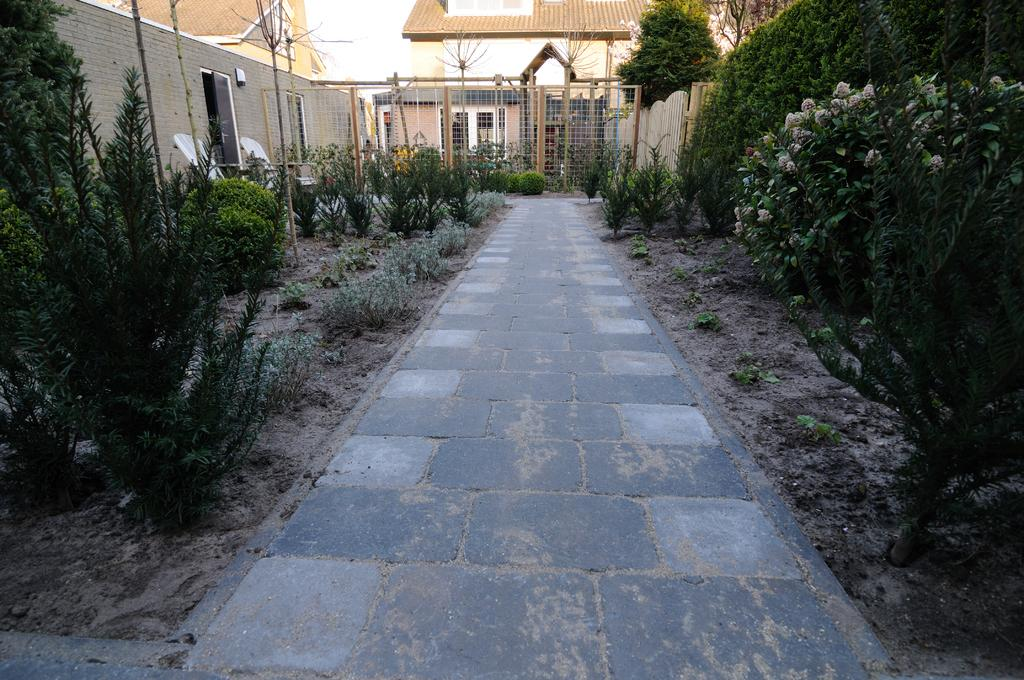What is the main feature in the middle of the image? There is a path in the middle of the image. What can be seen on either side of the path? There are plants and trees on either side of the path. What is visible in the background of the image? There are buildings in the background of the image. What type of boundary can be seen in the image? There is a net boundary visible in the image. What type of coal is being used to fuel the science experiment in the image? There is no coal or science experiment present in the image. What type of plant is growing on the left side of the path in the image? The provided facts do not specify the type of plants or trees on either side of the path, so we cannot determine the type of plant on the left side. 